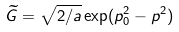<formula> <loc_0><loc_0><loc_500><loc_500>\widetilde { G } = \sqrt { 2 / a } \exp ( p _ { 0 } ^ { 2 } - p ^ { 2 } )</formula> 